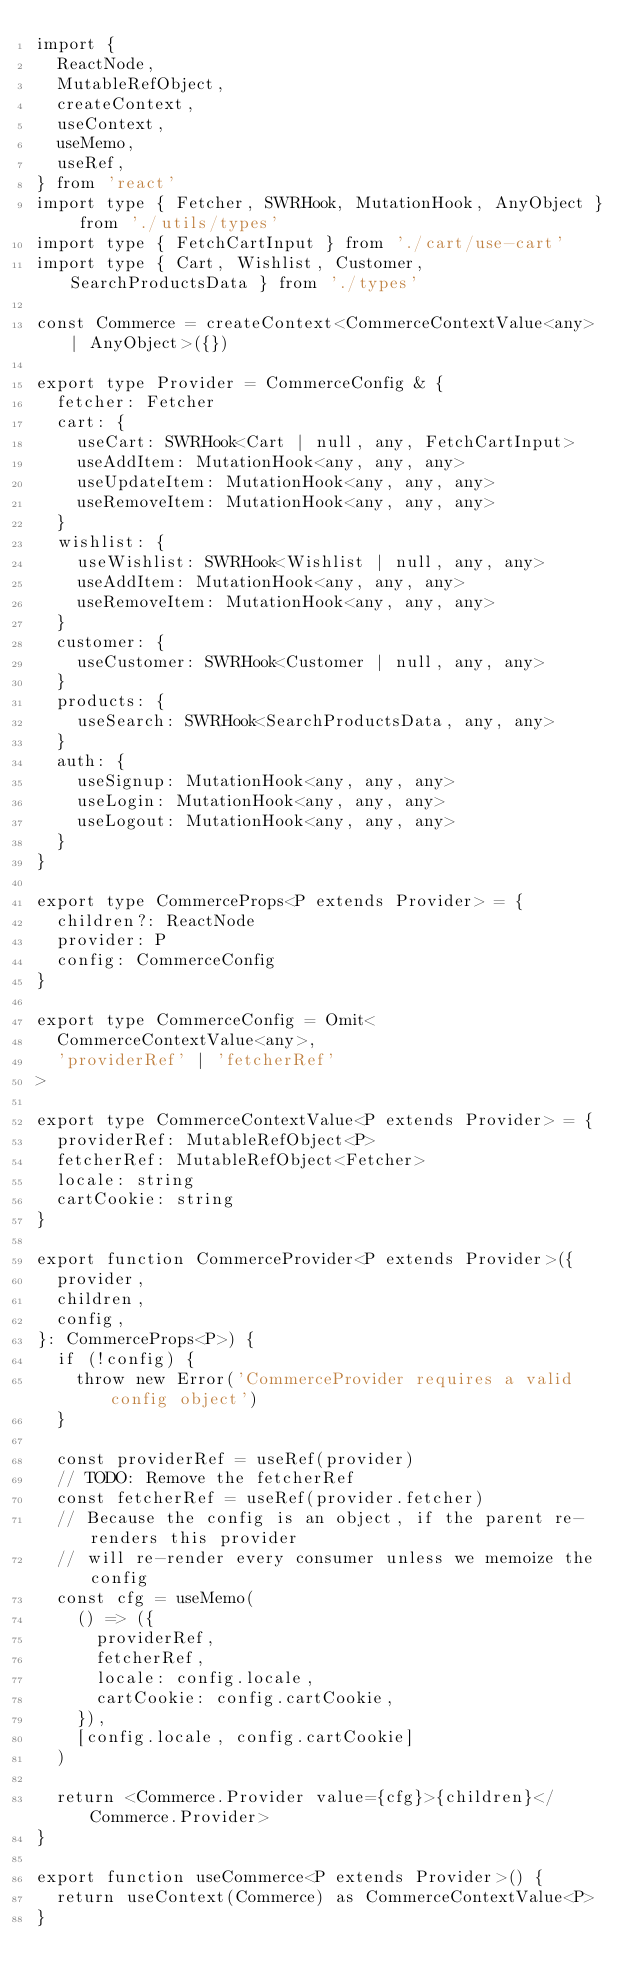<code> <loc_0><loc_0><loc_500><loc_500><_TypeScript_>import {
  ReactNode,
  MutableRefObject,
  createContext,
  useContext,
  useMemo,
  useRef,
} from 'react'
import type { Fetcher, SWRHook, MutationHook, AnyObject } from './utils/types'
import type { FetchCartInput } from './cart/use-cart'
import type { Cart, Wishlist, Customer, SearchProductsData } from './types'

const Commerce = createContext<CommerceContextValue<any> | AnyObject>({})

export type Provider = CommerceConfig & {
  fetcher: Fetcher
  cart: {
    useCart: SWRHook<Cart | null, any, FetchCartInput>
    useAddItem: MutationHook<any, any, any>
    useUpdateItem: MutationHook<any, any, any>
    useRemoveItem: MutationHook<any, any, any>
  }
  wishlist: {
    useWishlist: SWRHook<Wishlist | null, any, any>
    useAddItem: MutationHook<any, any, any>
    useRemoveItem: MutationHook<any, any, any>
  }
  customer: {
    useCustomer: SWRHook<Customer | null, any, any>
  }
  products: {
    useSearch: SWRHook<SearchProductsData, any, any>
  }
  auth: {
    useSignup: MutationHook<any, any, any>
    useLogin: MutationHook<any, any, any>
    useLogout: MutationHook<any, any, any>
  }
}

export type CommerceProps<P extends Provider> = {
  children?: ReactNode
  provider: P
  config: CommerceConfig
}

export type CommerceConfig = Omit<
  CommerceContextValue<any>,
  'providerRef' | 'fetcherRef'
>

export type CommerceContextValue<P extends Provider> = {
  providerRef: MutableRefObject<P>
  fetcherRef: MutableRefObject<Fetcher>
  locale: string
  cartCookie: string
}

export function CommerceProvider<P extends Provider>({
  provider,
  children,
  config,
}: CommerceProps<P>) {
  if (!config) {
    throw new Error('CommerceProvider requires a valid config object')
  }

  const providerRef = useRef(provider)
  // TODO: Remove the fetcherRef
  const fetcherRef = useRef(provider.fetcher)
  // Because the config is an object, if the parent re-renders this provider
  // will re-render every consumer unless we memoize the config
  const cfg = useMemo(
    () => ({
      providerRef,
      fetcherRef,
      locale: config.locale,
      cartCookie: config.cartCookie,
    }),
    [config.locale, config.cartCookie]
  )

  return <Commerce.Provider value={cfg}>{children}</Commerce.Provider>
}

export function useCommerce<P extends Provider>() {
  return useContext(Commerce) as CommerceContextValue<P>
}
</code> 